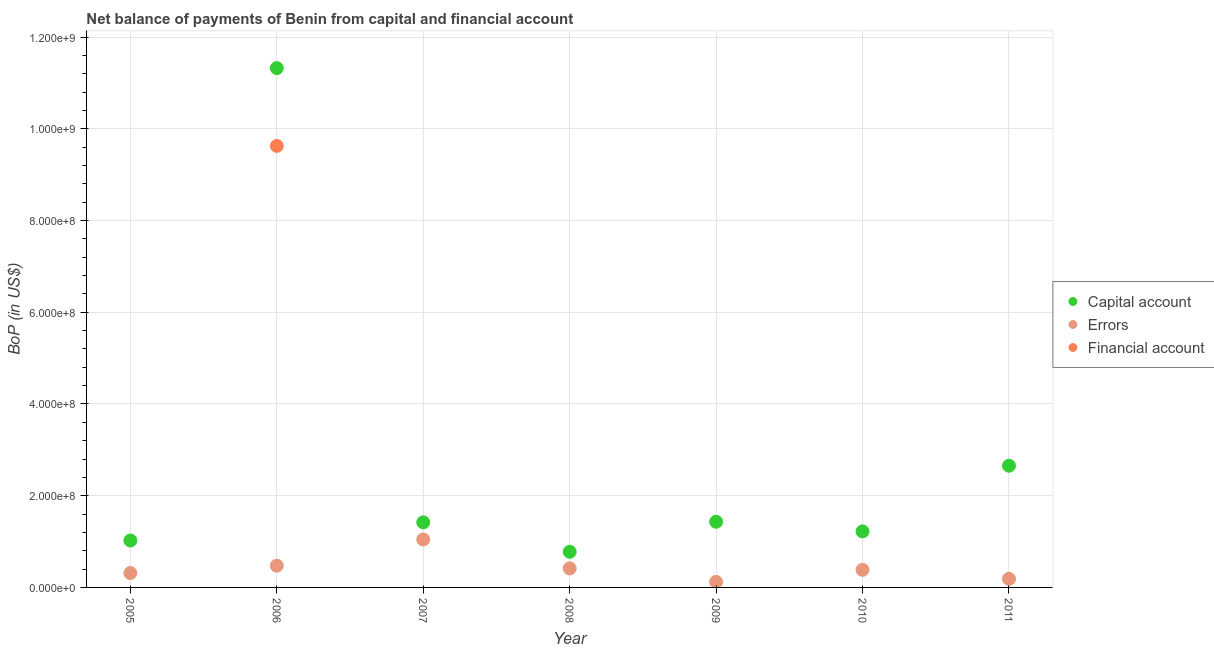How many different coloured dotlines are there?
Give a very brief answer. 3. Is the number of dotlines equal to the number of legend labels?
Make the answer very short. No. Across all years, what is the maximum amount of net capital account?
Ensure brevity in your answer.  1.13e+09. Across all years, what is the minimum amount of net capital account?
Your answer should be compact. 7.77e+07. In which year was the amount of errors maximum?
Give a very brief answer. 2007. What is the total amount of errors in the graph?
Offer a very short reply. 2.94e+08. What is the difference between the amount of net capital account in 2005 and that in 2009?
Your response must be concise. -4.09e+07. What is the difference between the amount of errors in 2011 and the amount of financial account in 2008?
Ensure brevity in your answer.  1.87e+07. What is the average amount of errors per year?
Ensure brevity in your answer.  4.20e+07. In the year 2007, what is the difference between the amount of net capital account and amount of errors?
Provide a short and direct response. 3.74e+07. What is the ratio of the amount of net capital account in 2006 to that in 2009?
Give a very brief answer. 7.91. Is the amount of errors in 2006 less than that in 2009?
Offer a very short reply. No. Is the difference between the amount of net capital account in 2006 and 2009 greater than the difference between the amount of errors in 2006 and 2009?
Make the answer very short. Yes. What is the difference between the highest and the second highest amount of errors?
Offer a terse response. 5.71e+07. What is the difference between the highest and the lowest amount of errors?
Provide a short and direct response. 9.24e+07. In how many years, is the amount of financial account greater than the average amount of financial account taken over all years?
Provide a succinct answer. 1. Does the amount of net capital account monotonically increase over the years?
Your answer should be compact. No. Is the amount of errors strictly less than the amount of financial account over the years?
Your answer should be very brief. No. Does the graph contain any zero values?
Provide a succinct answer. Yes. How many legend labels are there?
Your answer should be compact. 3. How are the legend labels stacked?
Make the answer very short. Vertical. What is the title of the graph?
Your response must be concise. Net balance of payments of Benin from capital and financial account. Does "Ages 15-20" appear as one of the legend labels in the graph?
Make the answer very short. No. What is the label or title of the Y-axis?
Your response must be concise. BoP (in US$). What is the BoP (in US$) in Capital account in 2005?
Your answer should be compact. 1.02e+08. What is the BoP (in US$) of Errors in 2005?
Keep it short and to the point. 3.14e+07. What is the BoP (in US$) of Capital account in 2006?
Give a very brief answer. 1.13e+09. What is the BoP (in US$) in Errors in 2006?
Give a very brief answer. 4.74e+07. What is the BoP (in US$) of Financial account in 2006?
Provide a succinct answer. 9.63e+08. What is the BoP (in US$) of Capital account in 2007?
Give a very brief answer. 1.42e+08. What is the BoP (in US$) of Errors in 2007?
Your response must be concise. 1.05e+08. What is the BoP (in US$) of Capital account in 2008?
Keep it short and to the point. 7.77e+07. What is the BoP (in US$) in Errors in 2008?
Keep it short and to the point. 4.16e+07. What is the BoP (in US$) of Financial account in 2008?
Your answer should be compact. 0. What is the BoP (in US$) of Capital account in 2009?
Offer a very short reply. 1.43e+08. What is the BoP (in US$) in Errors in 2009?
Your answer should be very brief. 1.21e+07. What is the BoP (in US$) of Capital account in 2010?
Ensure brevity in your answer.  1.22e+08. What is the BoP (in US$) of Errors in 2010?
Your response must be concise. 3.83e+07. What is the BoP (in US$) of Financial account in 2010?
Keep it short and to the point. 0. What is the BoP (in US$) of Capital account in 2011?
Offer a very short reply. 2.65e+08. What is the BoP (in US$) in Errors in 2011?
Offer a very short reply. 1.87e+07. What is the BoP (in US$) in Financial account in 2011?
Your response must be concise. 0. Across all years, what is the maximum BoP (in US$) in Capital account?
Ensure brevity in your answer.  1.13e+09. Across all years, what is the maximum BoP (in US$) in Errors?
Make the answer very short. 1.05e+08. Across all years, what is the maximum BoP (in US$) in Financial account?
Give a very brief answer. 9.63e+08. Across all years, what is the minimum BoP (in US$) in Capital account?
Provide a short and direct response. 7.77e+07. Across all years, what is the minimum BoP (in US$) of Errors?
Your answer should be compact. 1.21e+07. Across all years, what is the minimum BoP (in US$) in Financial account?
Keep it short and to the point. 0. What is the total BoP (in US$) in Capital account in the graph?
Provide a succinct answer. 1.99e+09. What is the total BoP (in US$) in Errors in the graph?
Make the answer very short. 2.94e+08. What is the total BoP (in US$) of Financial account in the graph?
Provide a succinct answer. 9.63e+08. What is the difference between the BoP (in US$) in Capital account in 2005 and that in 2006?
Your response must be concise. -1.03e+09. What is the difference between the BoP (in US$) in Errors in 2005 and that in 2006?
Your answer should be compact. -1.60e+07. What is the difference between the BoP (in US$) in Capital account in 2005 and that in 2007?
Provide a succinct answer. -3.95e+07. What is the difference between the BoP (in US$) of Errors in 2005 and that in 2007?
Your response must be concise. -7.31e+07. What is the difference between the BoP (in US$) in Capital account in 2005 and that in 2008?
Offer a terse response. 2.46e+07. What is the difference between the BoP (in US$) in Errors in 2005 and that in 2008?
Ensure brevity in your answer.  -1.01e+07. What is the difference between the BoP (in US$) in Capital account in 2005 and that in 2009?
Your answer should be compact. -4.09e+07. What is the difference between the BoP (in US$) of Errors in 2005 and that in 2009?
Your answer should be compact. 1.93e+07. What is the difference between the BoP (in US$) of Capital account in 2005 and that in 2010?
Make the answer very short. -1.99e+07. What is the difference between the BoP (in US$) of Errors in 2005 and that in 2010?
Your response must be concise. -6.91e+06. What is the difference between the BoP (in US$) in Capital account in 2005 and that in 2011?
Keep it short and to the point. -1.63e+08. What is the difference between the BoP (in US$) in Errors in 2005 and that in 2011?
Provide a short and direct response. 1.27e+07. What is the difference between the BoP (in US$) in Capital account in 2006 and that in 2007?
Your answer should be compact. 9.90e+08. What is the difference between the BoP (in US$) in Errors in 2006 and that in 2007?
Make the answer very short. -5.71e+07. What is the difference between the BoP (in US$) in Capital account in 2006 and that in 2008?
Provide a short and direct response. 1.05e+09. What is the difference between the BoP (in US$) in Errors in 2006 and that in 2008?
Your answer should be compact. 5.85e+06. What is the difference between the BoP (in US$) of Capital account in 2006 and that in 2009?
Your answer should be very brief. 9.89e+08. What is the difference between the BoP (in US$) of Errors in 2006 and that in 2009?
Give a very brief answer. 3.53e+07. What is the difference between the BoP (in US$) in Capital account in 2006 and that in 2010?
Make the answer very short. 1.01e+09. What is the difference between the BoP (in US$) in Errors in 2006 and that in 2010?
Make the answer very short. 9.08e+06. What is the difference between the BoP (in US$) in Capital account in 2006 and that in 2011?
Ensure brevity in your answer.  8.67e+08. What is the difference between the BoP (in US$) of Errors in 2006 and that in 2011?
Offer a very short reply. 2.87e+07. What is the difference between the BoP (in US$) of Capital account in 2007 and that in 2008?
Your response must be concise. 6.42e+07. What is the difference between the BoP (in US$) of Errors in 2007 and that in 2008?
Provide a succinct answer. 6.29e+07. What is the difference between the BoP (in US$) of Capital account in 2007 and that in 2009?
Offer a terse response. -1.34e+06. What is the difference between the BoP (in US$) of Errors in 2007 and that in 2009?
Your response must be concise. 9.24e+07. What is the difference between the BoP (in US$) of Capital account in 2007 and that in 2010?
Ensure brevity in your answer.  1.97e+07. What is the difference between the BoP (in US$) in Errors in 2007 and that in 2010?
Give a very brief answer. 6.62e+07. What is the difference between the BoP (in US$) in Capital account in 2007 and that in 2011?
Your answer should be compact. -1.24e+08. What is the difference between the BoP (in US$) of Errors in 2007 and that in 2011?
Give a very brief answer. 8.58e+07. What is the difference between the BoP (in US$) in Capital account in 2008 and that in 2009?
Make the answer very short. -6.55e+07. What is the difference between the BoP (in US$) in Errors in 2008 and that in 2009?
Make the answer very short. 2.94e+07. What is the difference between the BoP (in US$) in Capital account in 2008 and that in 2010?
Provide a short and direct response. -4.45e+07. What is the difference between the BoP (in US$) in Errors in 2008 and that in 2010?
Your answer should be compact. 3.22e+06. What is the difference between the BoP (in US$) of Capital account in 2008 and that in 2011?
Ensure brevity in your answer.  -1.88e+08. What is the difference between the BoP (in US$) of Errors in 2008 and that in 2011?
Give a very brief answer. 2.28e+07. What is the difference between the BoP (in US$) in Capital account in 2009 and that in 2010?
Offer a terse response. 2.10e+07. What is the difference between the BoP (in US$) of Errors in 2009 and that in 2010?
Offer a very short reply. -2.62e+07. What is the difference between the BoP (in US$) in Capital account in 2009 and that in 2011?
Offer a terse response. -1.22e+08. What is the difference between the BoP (in US$) in Errors in 2009 and that in 2011?
Keep it short and to the point. -6.57e+06. What is the difference between the BoP (in US$) in Capital account in 2010 and that in 2011?
Your response must be concise. -1.43e+08. What is the difference between the BoP (in US$) in Errors in 2010 and that in 2011?
Offer a terse response. 1.96e+07. What is the difference between the BoP (in US$) in Capital account in 2005 and the BoP (in US$) in Errors in 2006?
Provide a short and direct response. 5.49e+07. What is the difference between the BoP (in US$) in Capital account in 2005 and the BoP (in US$) in Financial account in 2006?
Give a very brief answer. -8.60e+08. What is the difference between the BoP (in US$) in Errors in 2005 and the BoP (in US$) in Financial account in 2006?
Offer a terse response. -9.31e+08. What is the difference between the BoP (in US$) in Capital account in 2005 and the BoP (in US$) in Errors in 2007?
Ensure brevity in your answer.  -2.18e+06. What is the difference between the BoP (in US$) of Capital account in 2005 and the BoP (in US$) of Errors in 2008?
Your answer should be compact. 6.08e+07. What is the difference between the BoP (in US$) of Capital account in 2005 and the BoP (in US$) of Errors in 2009?
Provide a succinct answer. 9.02e+07. What is the difference between the BoP (in US$) in Capital account in 2005 and the BoP (in US$) in Errors in 2010?
Offer a terse response. 6.40e+07. What is the difference between the BoP (in US$) of Capital account in 2005 and the BoP (in US$) of Errors in 2011?
Make the answer very short. 8.36e+07. What is the difference between the BoP (in US$) in Capital account in 2006 and the BoP (in US$) in Errors in 2007?
Keep it short and to the point. 1.03e+09. What is the difference between the BoP (in US$) of Capital account in 2006 and the BoP (in US$) of Errors in 2008?
Offer a very short reply. 1.09e+09. What is the difference between the BoP (in US$) of Capital account in 2006 and the BoP (in US$) of Errors in 2009?
Offer a very short reply. 1.12e+09. What is the difference between the BoP (in US$) in Capital account in 2006 and the BoP (in US$) in Errors in 2010?
Give a very brief answer. 1.09e+09. What is the difference between the BoP (in US$) of Capital account in 2006 and the BoP (in US$) of Errors in 2011?
Keep it short and to the point. 1.11e+09. What is the difference between the BoP (in US$) in Capital account in 2007 and the BoP (in US$) in Errors in 2008?
Your answer should be very brief. 1.00e+08. What is the difference between the BoP (in US$) of Capital account in 2007 and the BoP (in US$) of Errors in 2009?
Ensure brevity in your answer.  1.30e+08. What is the difference between the BoP (in US$) in Capital account in 2007 and the BoP (in US$) in Errors in 2010?
Ensure brevity in your answer.  1.04e+08. What is the difference between the BoP (in US$) of Capital account in 2007 and the BoP (in US$) of Errors in 2011?
Keep it short and to the point. 1.23e+08. What is the difference between the BoP (in US$) in Capital account in 2008 and the BoP (in US$) in Errors in 2009?
Ensure brevity in your answer.  6.55e+07. What is the difference between the BoP (in US$) in Capital account in 2008 and the BoP (in US$) in Errors in 2010?
Make the answer very short. 3.94e+07. What is the difference between the BoP (in US$) of Capital account in 2008 and the BoP (in US$) of Errors in 2011?
Offer a very short reply. 5.90e+07. What is the difference between the BoP (in US$) of Capital account in 2009 and the BoP (in US$) of Errors in 2010?
Make the answer very short. 1.05e+08. What is the difference between the BoP (in US$) in Capital account in 2009 and the BoP (in US$) in Errors in 2011?
Provide a short and direct response. 1.24e+08. What is the difference between the BoP (in US$) in Capital account in 2010 and the BoP (in US$) in Errors in 2011?
Provide a succinct answer. 1.03e+08. What is the average BoP (in US$) of Capital account per year?
Keep it short and to the point. 2.84e+08. What is the average BoP (in US$) in Errors per year?
Offer a very short reply. 4.20e+07. What is the average BoP (in US$) of Financial account per year?
Your answer should be very brief. 1.38e+08. In the year 2005, what is the difference between the BoP (in US$) of Capital account and BoP (in US$) of Errors?
Offer a very short reply. 7.09e+07. In the year 2006, what is the difference between the BoP (in US$) of Capital account and BoP (in US$) of Errors?
Provide a short and direct response. 1.08e+09. In the year 2006, what is the difference between the BoP (in US$) in Capital account and BoP (in US$) in Financial account?
Provide a short and direct response. 1.70e+08. In the year 2006, what is the difference between the BoP (in US$) of Errors and BoP (in US$) of Financial account?
Make the answer very short. -9.15e+08. In the year 2007, what is the difference between the BoP (in US$) of Capital account and BoP (in US$) of Errors?
Provide a succinct answer. 3.74e+07. In the year 2008, what is the difference between the BoP (in US$) in Capital account and BoP (in US$) in Errors?
Ensure brevity in your answer.  3.61e+07. In the year 2009, what is the difference between the BoP (in US$) in Capital account and BoP (in US$) in Errors?
Ensure brevity in your answer.  1.31e+08. In the year 2010, what is the difference between the BoP (in US$) in Capital account and BoP (in US$) in Errors?
Provide a succinct answer. 8.39e+07. In the year 2011, what is the difference between the BoP (in US$) of Capital account and BoP (in US$) of Errors?
Make the answer very short. 2.47e+08. What is the ratio of the BoP (in US$) of Capital account in 2005 to that in 2006?
Offer a terse response. 0.09. What is the ratio of the BoP (in US$) of Errors in 2005 to that in 2006?
Give a very brief answer. 0.66. What is the ratio of the BoP (in US$) in Capital account in 2005 to that in 2007?
Your answer should be very brief. 0.72. What is the ratio of the BoP (in US$) of Errors in 2005 to that in 2007?
Your response must be concise. 0.3. What is the ratio of the BoP (in US$) in Capital account in 2005 to that in 2008?
Your response must be concise. 1.32. What is the ratio of the BoP (in US$) in Errors in 2005 to that in 2008?
Provide a short and direct response. 0.76. What is the ratio of the BoP (in US$) of Capital account in 2005 to that in 2009?
Ensure brevity in your answer.  0.71. What is the ratio of the BoP (in US$) of Errors in 2005 to that in 2009?
Give a very brief answer. 2.59. What is the ratio of the BoP (in US$) of Capital account in 2005 to that in 2010?
Offer a very short reply. 0.84. What is the ratio of the BoP (in US$) in Errors in 2005 to that in 2010?
Offer a very short reply. 0.82. What is the ratio of the BoP (in US$) in Capital account in 2005 to that in 2011?
Offer a very short reply. 0.39. What is the ratio of the BoP (in US$) of Errors in 2005 to that in 2011?
Ensure brevity in your answer.  1.68. What is the ratio of the BoP (in US$) in Capital account in 2006 to that in 2007?
Make the answer very short. 7.98. What is the ratio of the BoP (in US$) of Errors in 2006 to that in 2007?
Your answer should be compact. 0.45. What is the ratio of the BoP (in US$) in Capital account in 2006 to that in 2008?
Your answer should be compact. 14.57. What is the ratio of the BoP (in US$) in Errors in 2006 to that in 2008?
Your answer should be very brief. 1.14. What is the ratio of the BoP (in US$) of Capital account in 2006 to that in 2009?
Your response must be concise. 7.91. What is the ratio of the BoP (in US$) of Errors in 2006 to that in 2009?
Give a very brief answer. 3.9. What is the ratio of the BoP (in US$) in Capital account in 2006 to that in 2010?
Make the answer very short. 9.27. What is the ratio of the BoP (in US$) of Errors in 2006 to that in 2010?
Offer a terse response. 1.24. What is the ratio of the BoP (in US$) in Capital account in 2006 to that in 2011?
Your answer should be compact. 4.27. What is the ratio of the BoP (in US$) in Errors in 2006 to that in 2011?
Make the answer very short. 2.53. What is the ratio of the BoP (in US$) in Capital account in 2007 to that in 2008?
Make the answer very short. 1.83. What is the ratio of the BoP (in US$) in Errors in 2007 to that in 2008?
Your response must be concise. 2.51. What is the ratio of the BoP (in US$) in Capital account in 2007 to that in 2009?
Keep it short and to the point. 0.99. What is the ratio of the BoP (in US$) of Errors in 2007 to that in 2009?
Your response must be concise. 8.6. What is the ratio of the BoP (in US$) in Capital account in 2007 to that in 2010?
Your response must be concise. 1.16. What is the ratio of the BoP (in US$) in Errors in 2007 to that in 2010?
Offer a very short reply. 2.73. What is the ratio of the BoP (in US$) in Capital account in 2007 to that in 2011?
Ensure brevity in your answer.  0.53. What is the ratio of the BoP (in US$) in Errors in 2007 to that in 2011?
Your answer should be compact. 5.58. What is the ratio of the BoP (in US$) in Capital account in 2008 to that in 2009?
Your answer should be compact. 0.54. What is the ratio of the BoP (in US$) of Errors in 2008 to that in 2009?
Give a very brief answer. 3.42. What is the ratio of the BoP (in US$) in Capital account in 2008 to that in 2010?
Give a very brief answer. 0.64. What is the ratio of the BoP (in US$) in Errors in 2008 to that in 2010?
Your answer should be compact. 1.08. What is the ratio of the BoP (in US$) of Capital account in 2008 to that in 2011?
Ensure brevity in your answer.  0.29. What is the ratio of the BoP (in US$) of Errors in 2008 to that in 2011?
Offer a very short reply. 2.22. What is the ratio of the BoP (in US$) of Capital account in 2009 to that in 2010?
Your answer should be very brief. 1.17. What is the ratio of the BoP (in US$) in Errors in 2009 to that in 2010?
Ensure brevity in your answer.  0.32. What is the ratio of the BoP (in US$) of Capital account in 2009 to that in 2011?
Provide a succinct answer. 0.54. What is the ratio of the BoP (in US$) of Errors in 2009 to that in 2011?
Ensure brevity in your answer.  0.65. What is the ratio of the BoP (in US$) of Capital account in 2010 to that in 2011?
Provide a short and direct response. 0.46. What is the ratio of the BoP (in US$) in Errors in 2010 to that in 2011?
Give a very brief answer. 2.05. What is the difference between the highest and the second highest BoP (in US$) of Capital account?
Give a very brief answer. 8.67e+08. What is the difference between the highest and the second highest BoP (in US$) of Errors?
Give a very brief answer. 5.71e+07. What is the difference between the highest and the lowest BoP (in US$) in Capital account?
Your answer should be very brief. 1.05e+09. What is the difference between the highest and the lowest BoP (in US$) in Errors?
Your answer should be very brief. 9.24e+07. What is the difference between the highest and the lowest BoP (in US$) of Financial account?
Ensure brevity in your answer.  9.63e+08. 